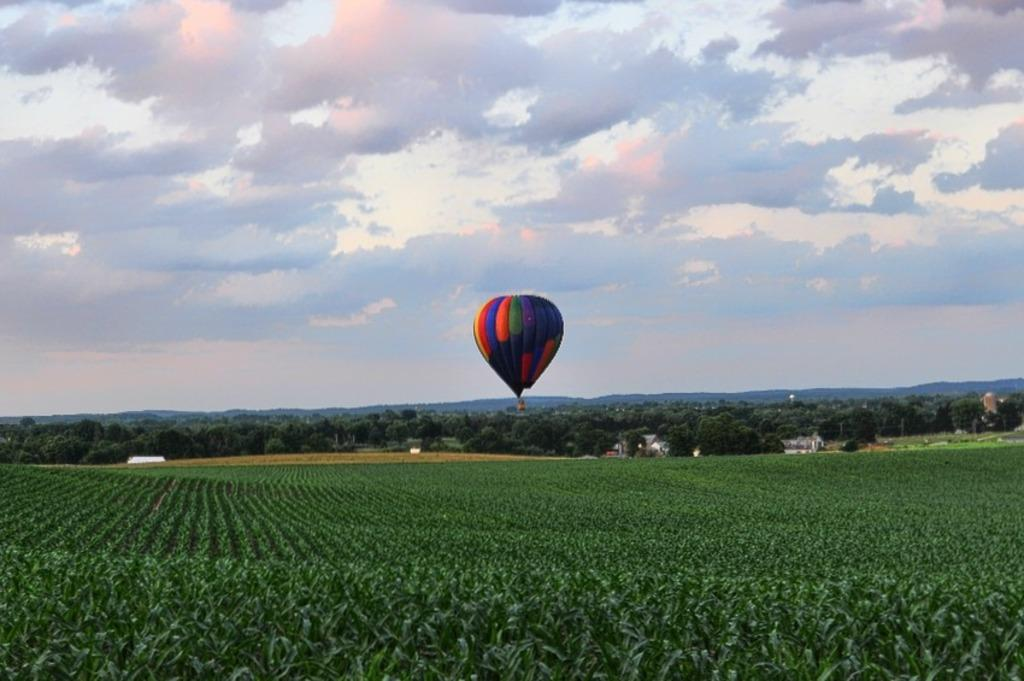What is the main object in the center of the image? There is a parachute in the center of the image. What can be seen at the bottom of the image? There are plants at the bottom of the image. What is visible in the background of the image? There are trees, buildings, the sky, and clouds in the background of the image. What type of cloth is being used to make the sound in the image? There is no cloth or sound present in the image. How far away is the parachute from the trees in the image? The distance between the parachute and the trees cannot be determined from the image, as there is no reference point to measure the distance. 